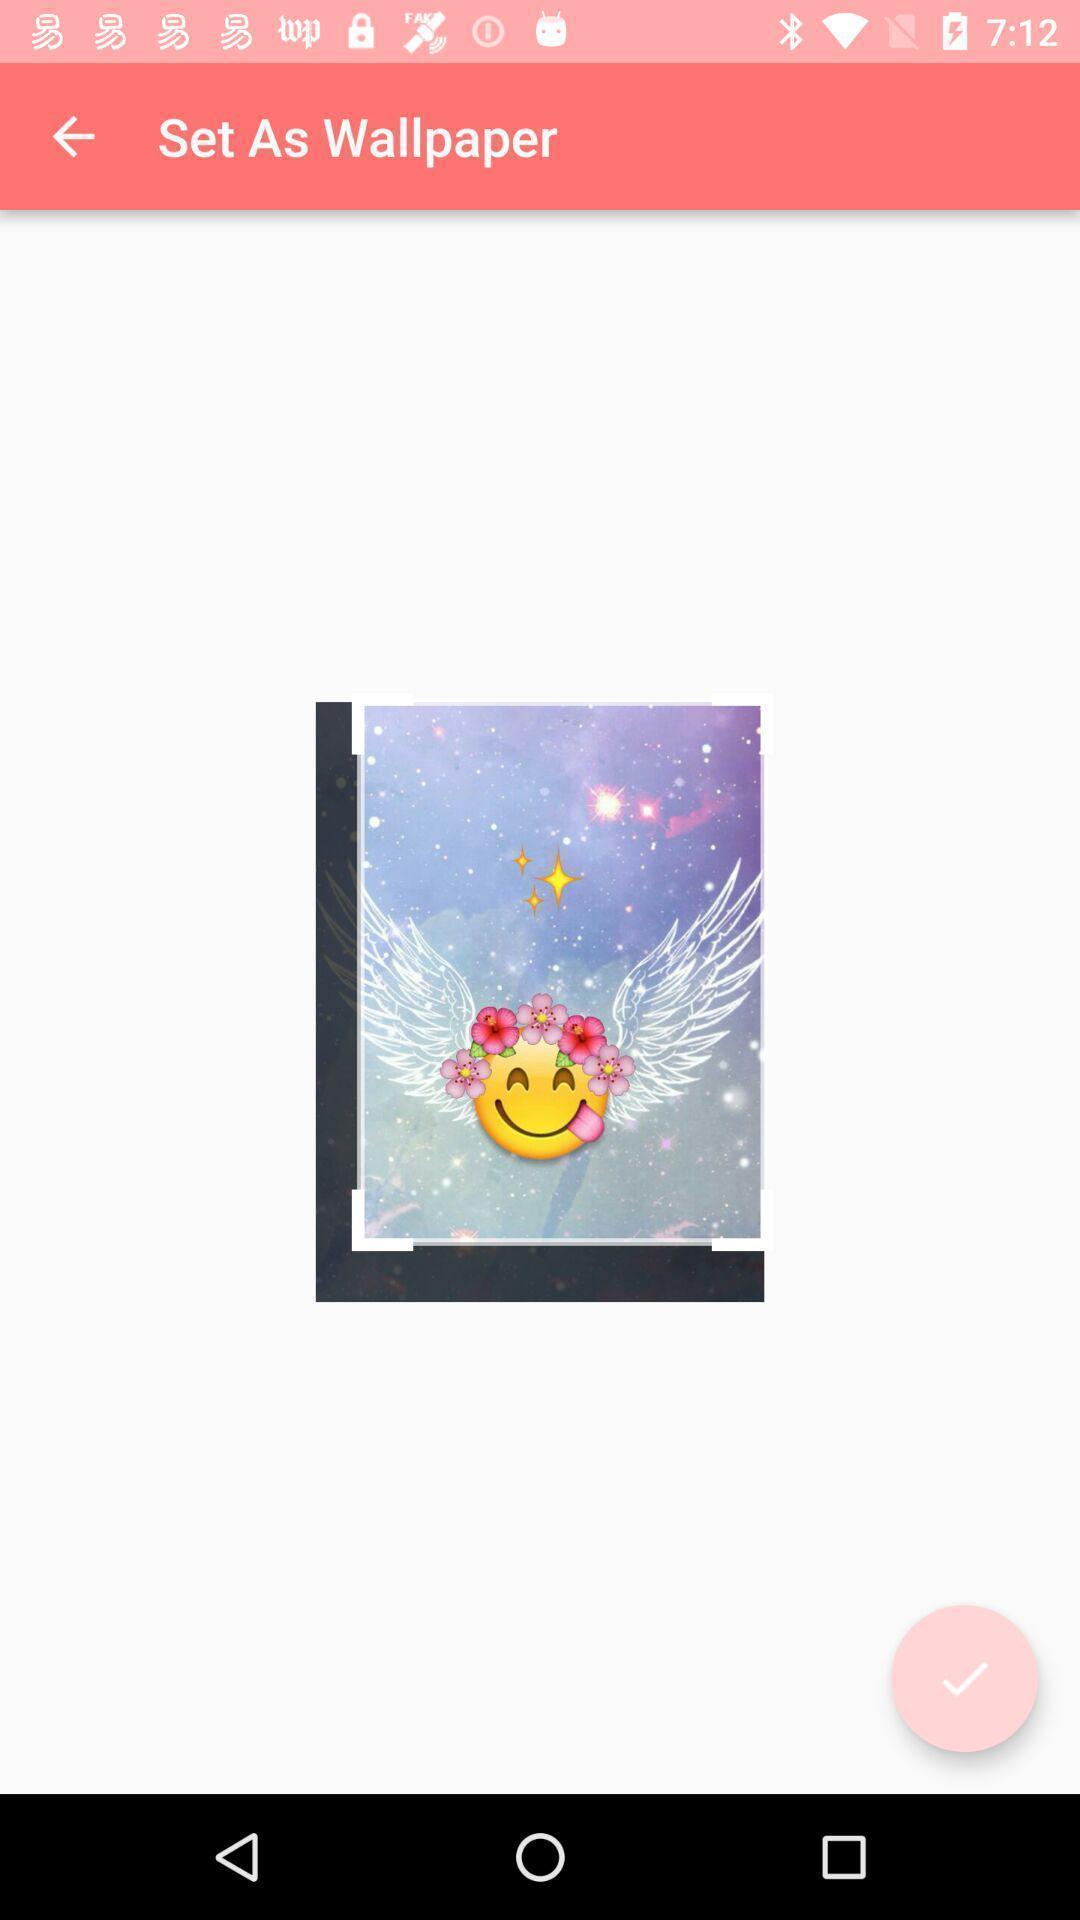What is the overall content of this screenshot? Screen showing set as wallpaper option in mobile. 